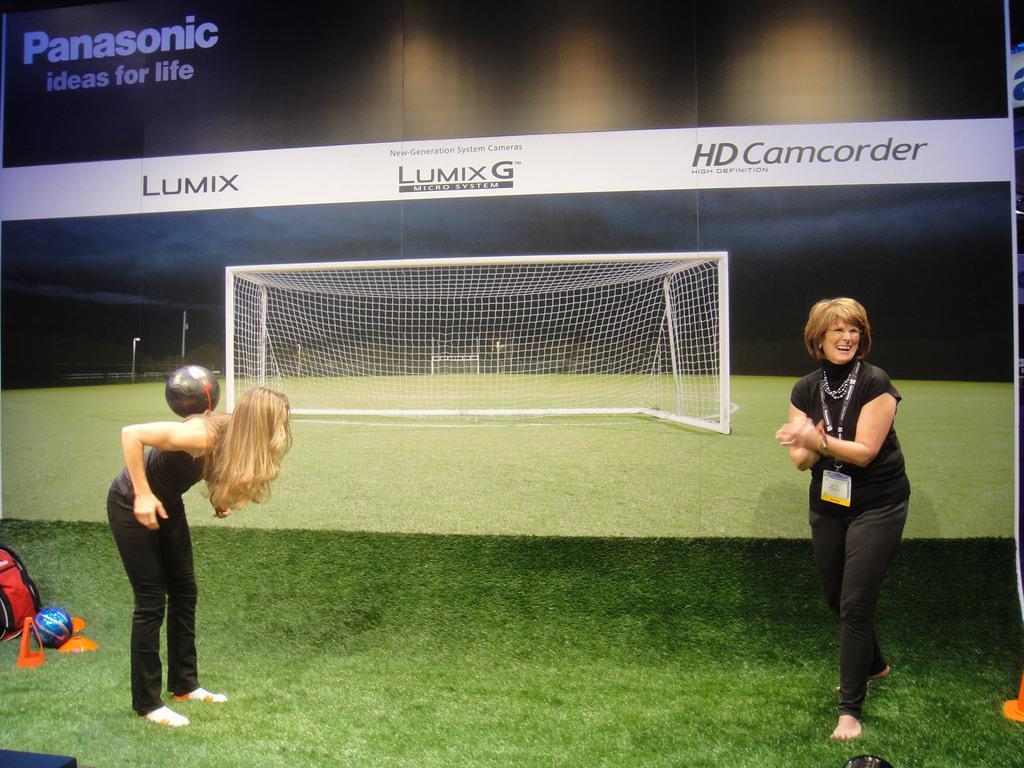Could you give a brief overview of what you see in this image? In the image we can see there are women standing on the ground and there's grass on the ground. There is a ball on the woman´s back and behind there is a banner on the wall. There is a net on the banner. 